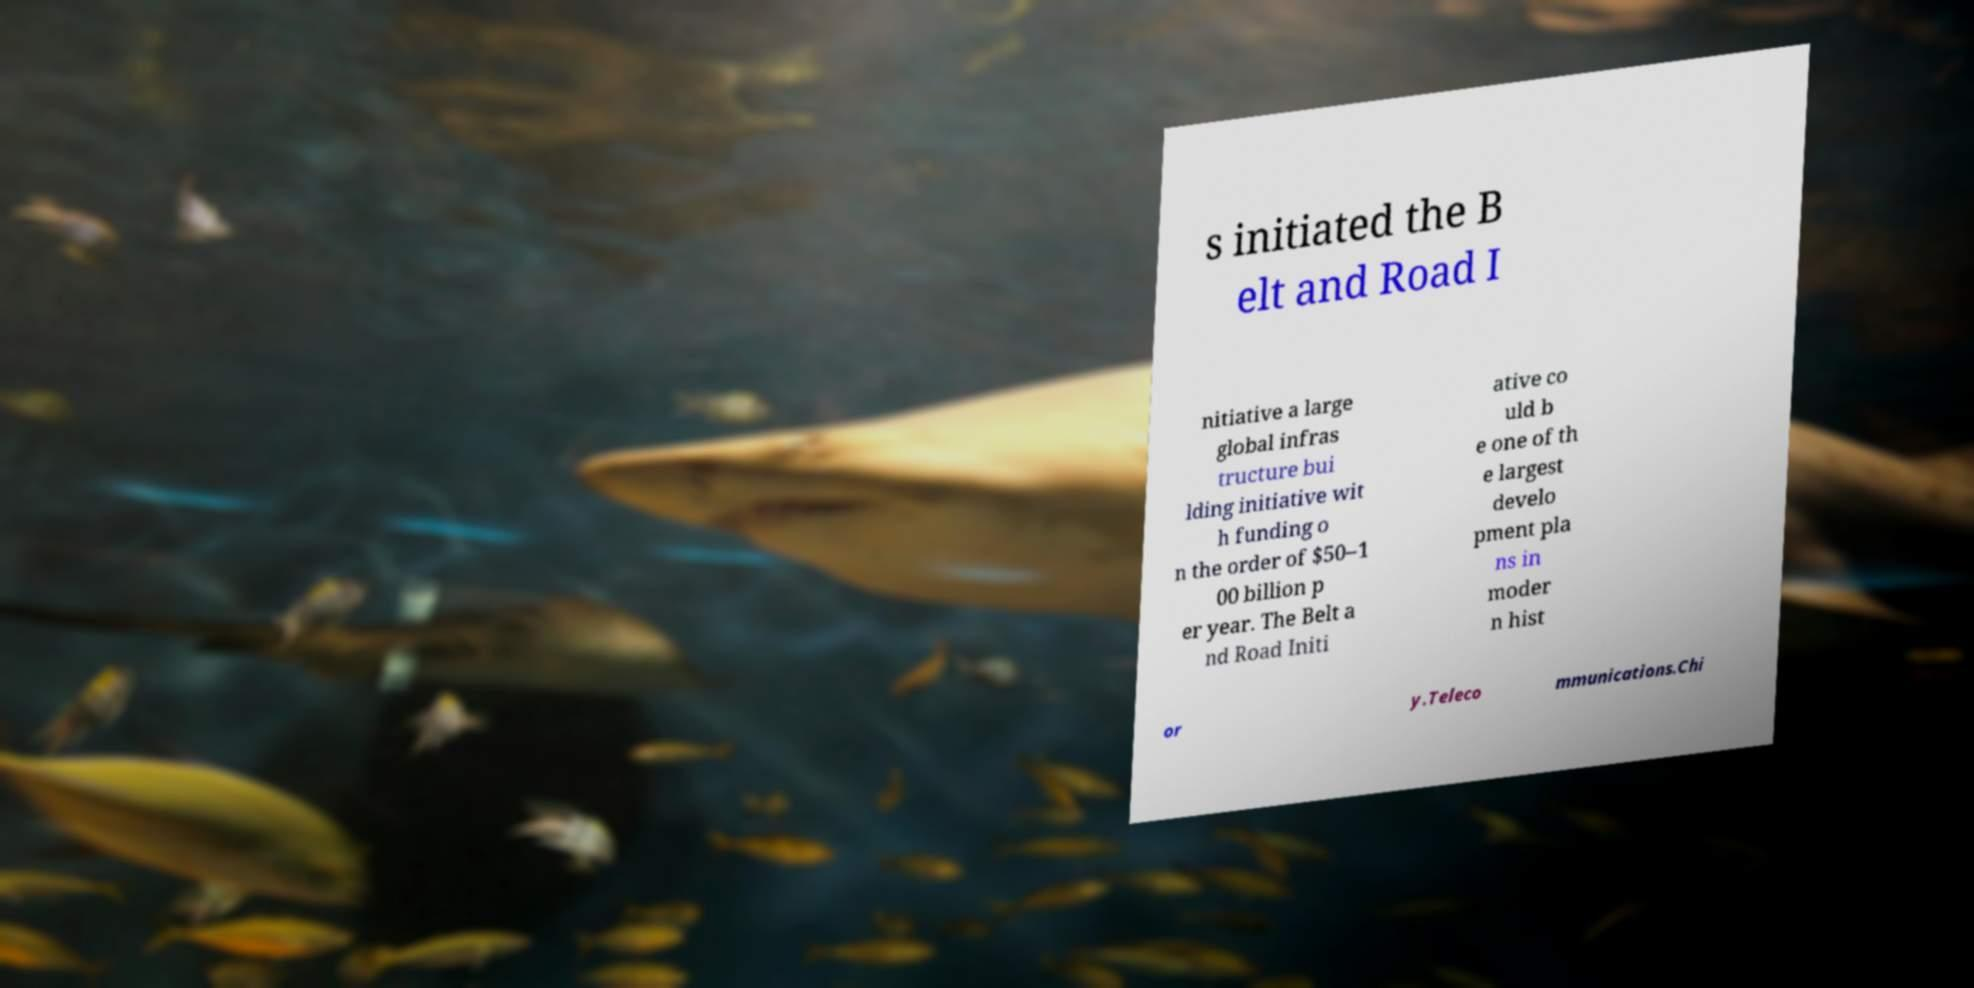Please read and relay the text visible in this image. What does it say? s initiated the B elt and Road I nitiative a large global infras tructure bui lding initiative wit h funding o n the order of $50–1 00 billion p er year. The Belt a nd Road Initi ative co uld b e one of th e largest develo pment pla ns in moder n hist or y.Teleco mmunications.Chi 